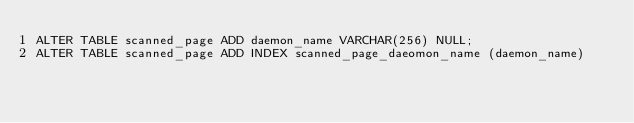<code> <loc_0><loc_0><loc_500><loc_500><_SQL_>ALTER TABLE scanned_page ADD daemon_name VARCHAR(256) NULL;
ALTER TABLE scanned_page ADD INDEX scanned_page_daeomon_name (daemon_name)</code> 